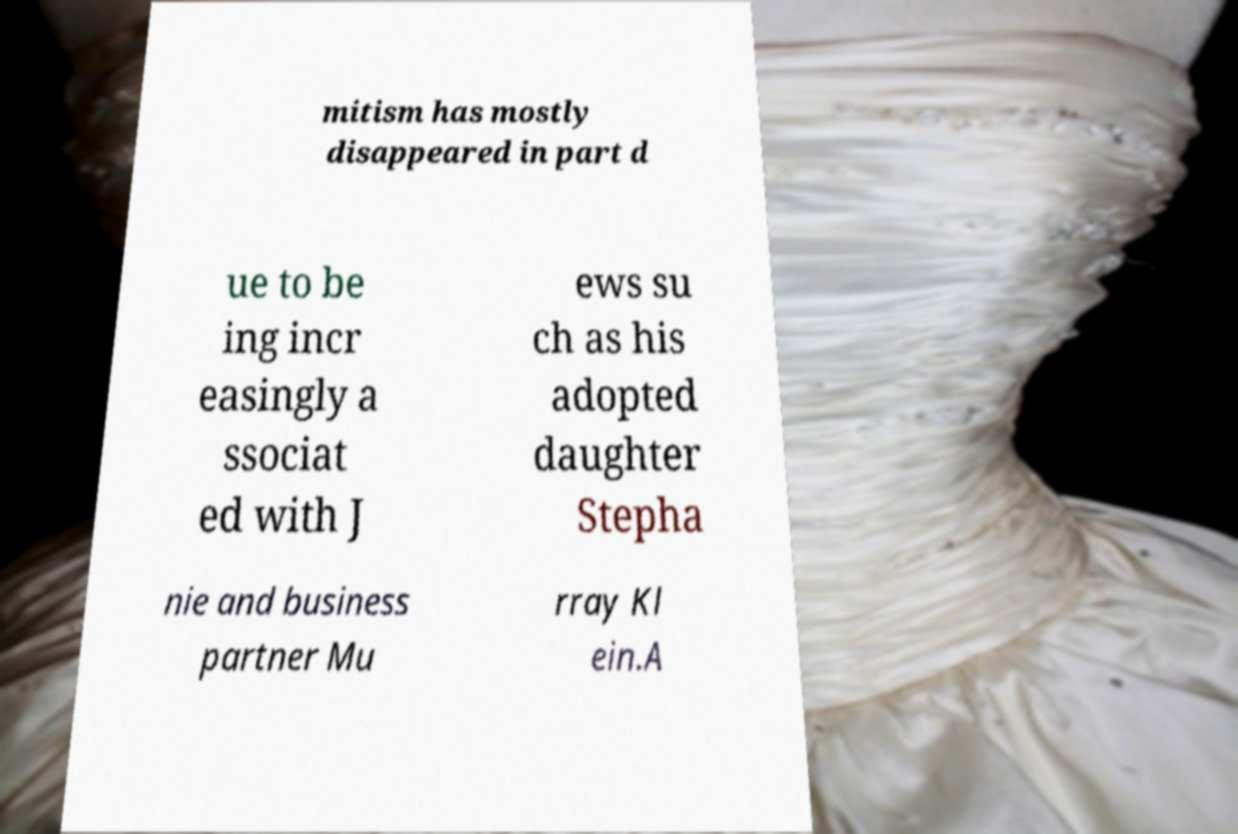Please read and relay the text visible in this image. What does it say? mitism has mostly disappeared in part d ue to be ing incr easingly a ssociat ed with J ews su ch as his adopted daughter Stepha nie and business partner Mu rray Kl ein.A 